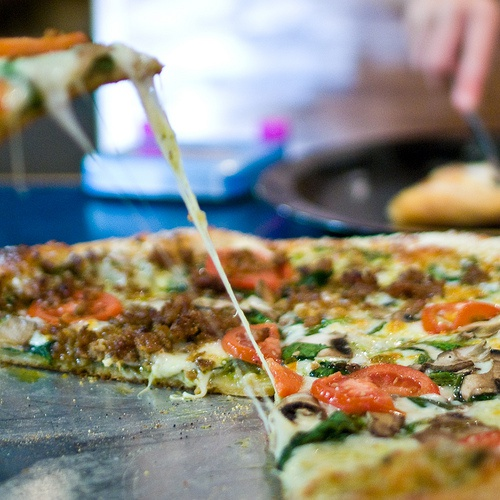Describe the objects in this image and their specific colors. I can see pizza in black, olive, tan, and beige tones, people in black, lavender, darkgray, and lightpink tones, and pizza in black, darkgray, tan, olive, and lightgray tones in this image. 